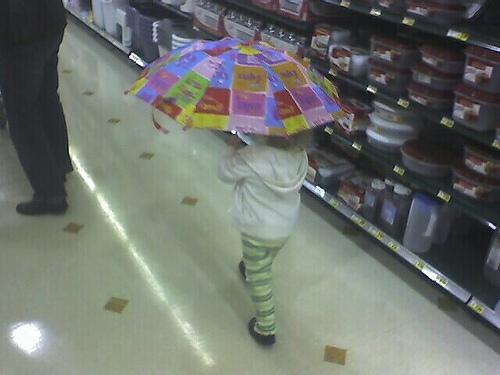What is the child holding?
Be succinct. Umbrella. What shapes are brown on the floor?
Be succinct. Squares. What are the objects next to the child on the shelves made of?
Quick response, please. Plastic. 